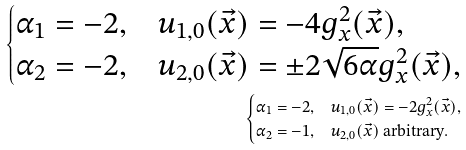Convert formula to latex. <formula><loc_0><loc_0><loc_500><loc_500>\begin{cases} \alpha _ { 1 } = - 2 , & u _ { 1 , 0 } ( \vec { x } ) = - 4 g _ { x } ^ { 2 } ( \vec { x } ) , \\ \alpha _ { 2 } = - 2 , & u _ { 2 , 0 } ( \vec { x } ) = \pm 2 \sqrt { 6 \alpha } g _ { x } ^ { 2 } ( \vec { x } ) , \end{cases} \\ \begin{cases} \alpha _ { 1 } = - 2 , & u _ { 1 , 0 } ( \vec { x } ) = - 2 g _ { x } ^ { 2 } ( \vec { x } ) , \\ \alpha _ { 2 } = - 1 , & u _ { 2 , 0 } ( \vec { x } ) \text { arbitrary} . \end{cases}</formula> 